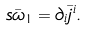<formula> <loc_0><loc_0><loc_500><loc_500>s \bar { \omega } _ { 1 } = \partial _ { i } \bar { j } ^ { i } .</formula> 